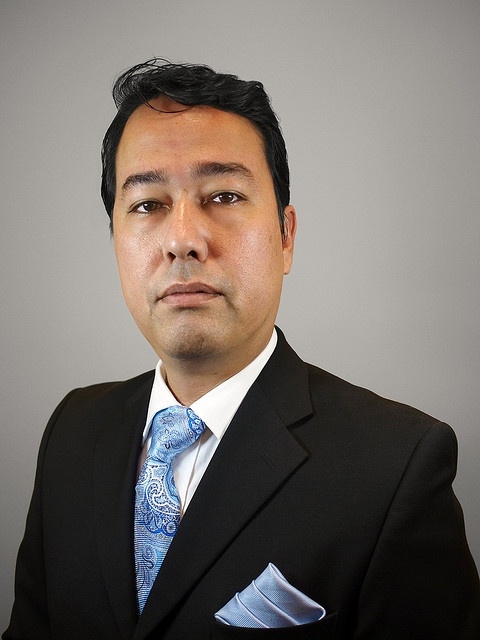Describe the objects in this image and their specific colors. I can see people in gray, black, and tan tones and tie in gray, darkgray, lightgray, and lightblue tones in this image. 